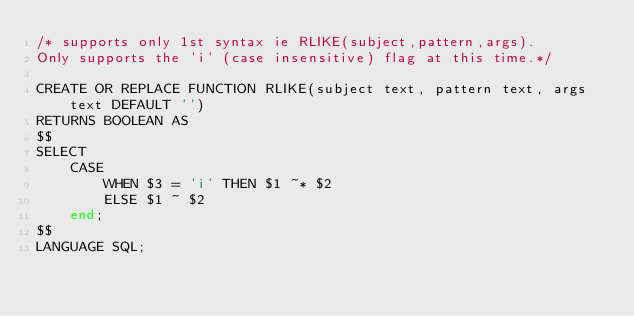<code> <loc_0><loc_0><loc_500><loc_500><_SQL_>/* supports only 1st syntax ie RLIKE(subject,pattern,args). 
Only supports the 'i' (case insensitive) flag at this time.*/

CREATE OR REPLACE FUNCTION RLIKE(subject text, pattern text, args text DEFAULT '')
RETURNS BOOLEAN AS 
$$
SELECT
	CASE 
		WHEN $3 = 'i' THEN $1 ~* $2
		ELSE $1 ~ $2
	end;
$$
LANGUAGE SQL;
</code> 